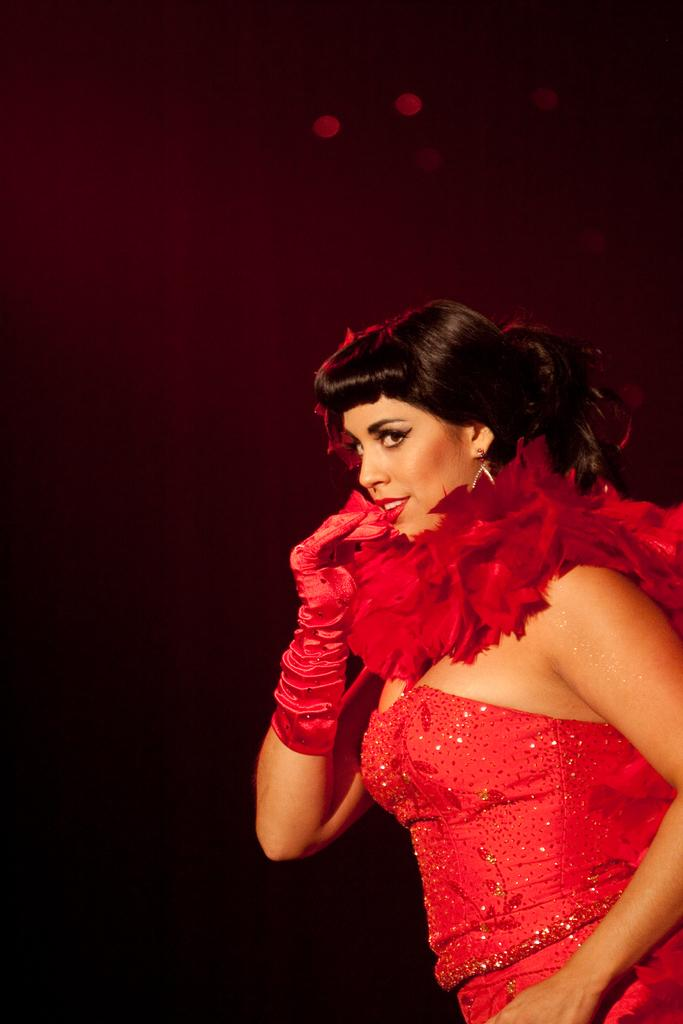Who is the main subject in the image? There is a woman in the image. What color is the woman wearing? The woman is wearing red. Where is the woman located in the image? The woman is on the right side of the image. What color can be seen in the background of the image? There is red color in the background of the image. Is there a toothbrush visible in the image? No, there is no toothbrush present in the image. Can you see a basketball being used by the woman in the image? No, there is no basketball visible in the image. 